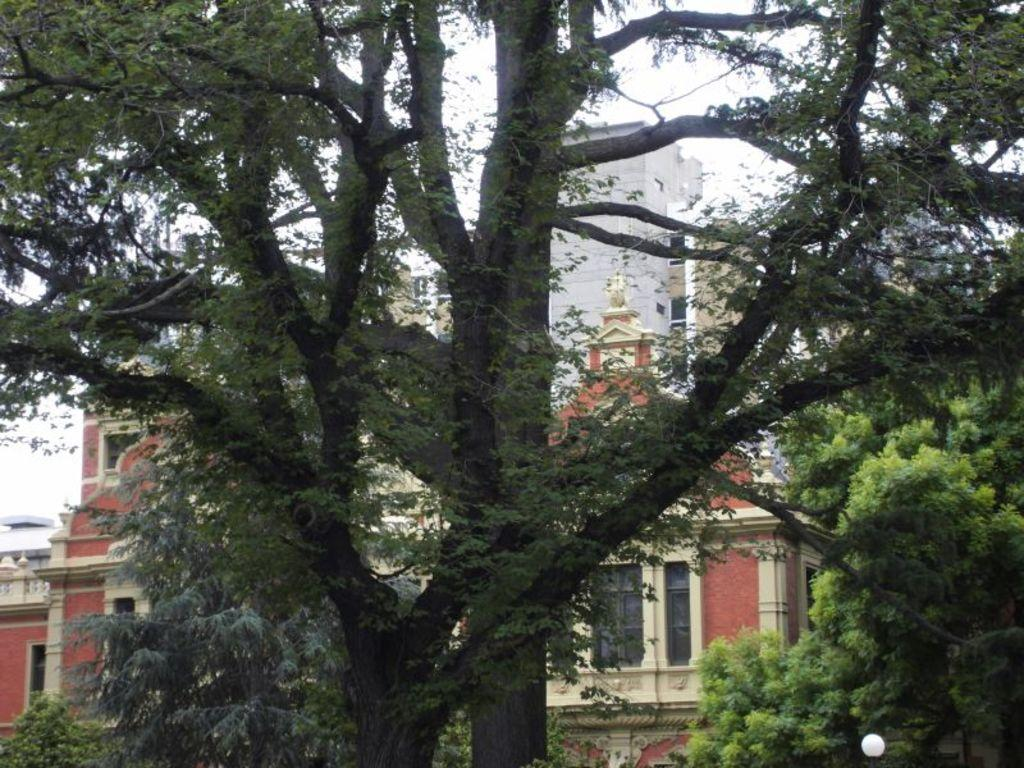What type of structures can be seen in the image? There are buildings in the image. What is located in the front of the image? There are trees in the front of the image. What is visible at the top of the image? The sky is visible at the top of the image. How many eyes can be seen on the buildings in the image? There are no eyes visible on the buildings in the image. What type of thrill can be experienced by the geese in the image? There are no geese present in the image, so it is not possible to determine if they are experiencing any thrill. 